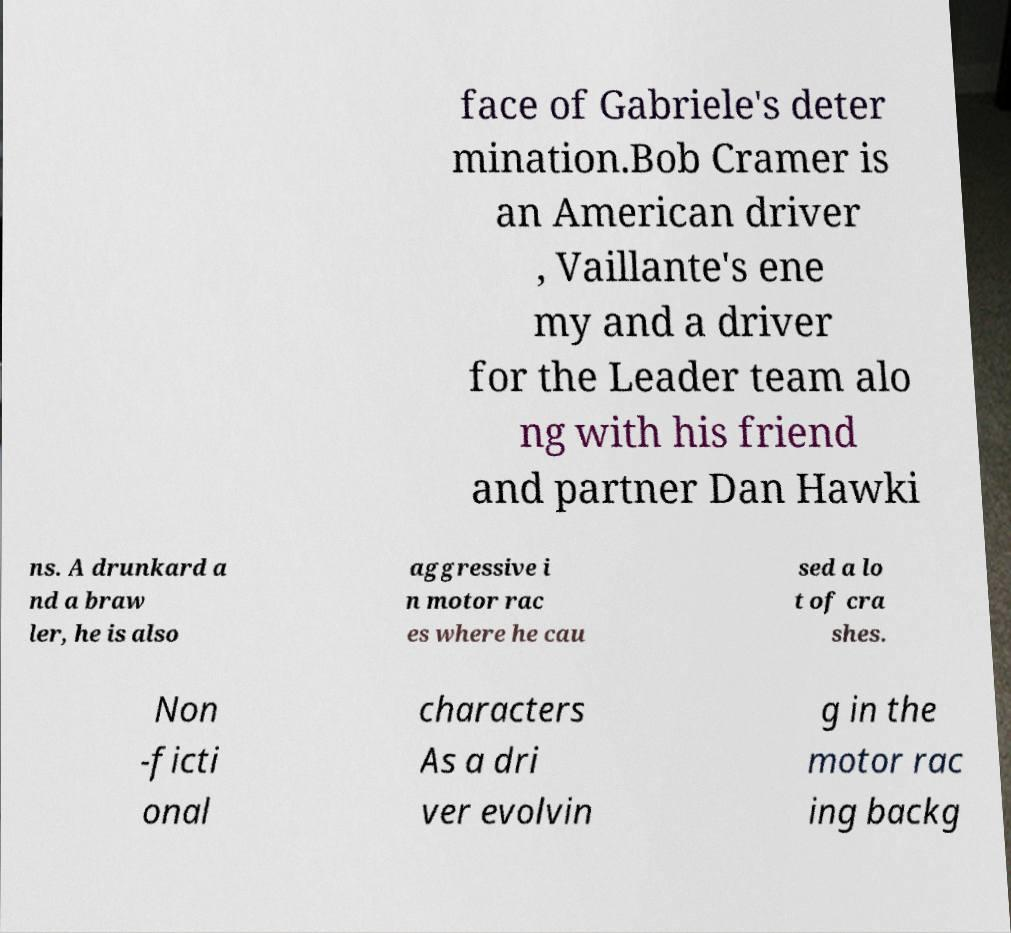Please identify and transcribe the text found in this image. face of Gabriele's deter mination.Bob Cramer is an American driver , Vaillante's ene my and a driver for the Leader team alo ng with his friend and partner Dan Hawki ns. A drunkard a nd a braw ler, he is also aggressive i n motor rac es where he cau sed a lo t of cra shes. Non -ficti onal characters As a dri ver evolvin g in the motor rac ing backg 